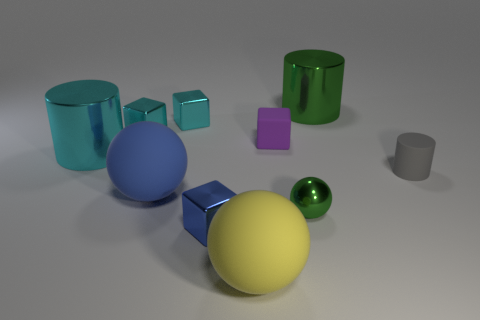How does the lighting affect the appearance of the objects? The lighting in the image seems to be soft and coming from above, creating gentle shadows and highlights that enhance the textures and dimensions of the objects. It adds depth to the scene and emphasizes the reflective qualities of some surfaces. 